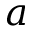Convert formula to latex. <formula><loc_0><loc_0><loc_500><loc_500>a</formula> 